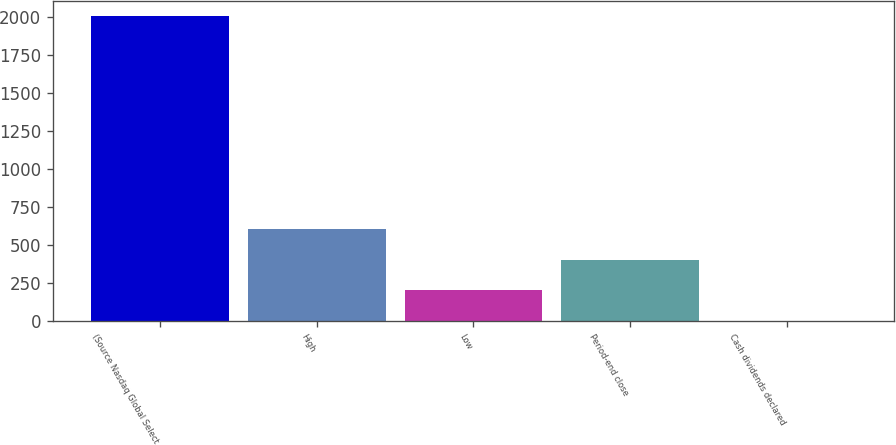Convert chart to OTSL. <chart><loc_0><loc_0><loc_500><loc_500><bar_chart><fcel>(Source Nasdaq Global Select<fcel>High<fcel>Low<fcel>Period-end close<fcel>Cash dividends declared<nl><fcel>2008<fcel>602.67<fcel>201.15<fcel>401.91<fcel>0.39<nl></chart> 